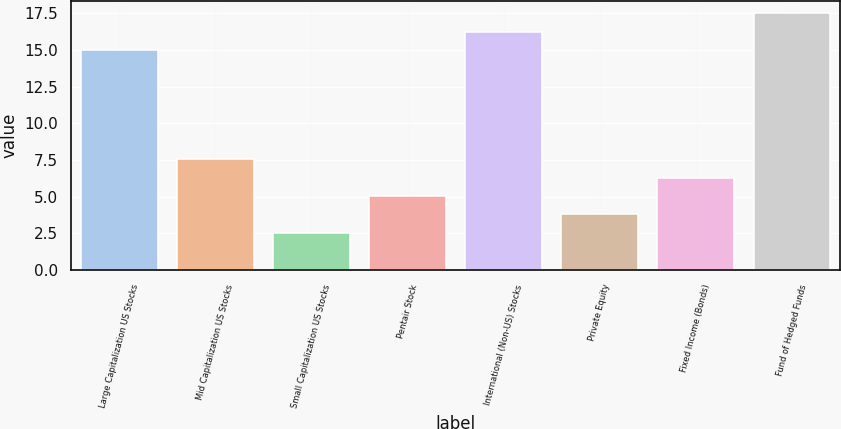Convert chart. <chart><loc_0><loc_0><loc_500><loc_500><bar_chart><fcel>Large Capitalization US Stocks<fcel>Mid Capitalization US Stocks<fcel>Small Capitalization US Stocks<fcel>Pentair Stock<fcel>International (Non-US) Stocks<fcel>Private Equity<fcel>Fixed Income (Bonds)<fcel>Fund of Hedged Funds<nl><fcel>15<fcel>7.55<fcel>2.5<fcel>5.05<fcel>16.25<fcel>3.8<fcel>6.3<fcel>17.5<nl></chart> 